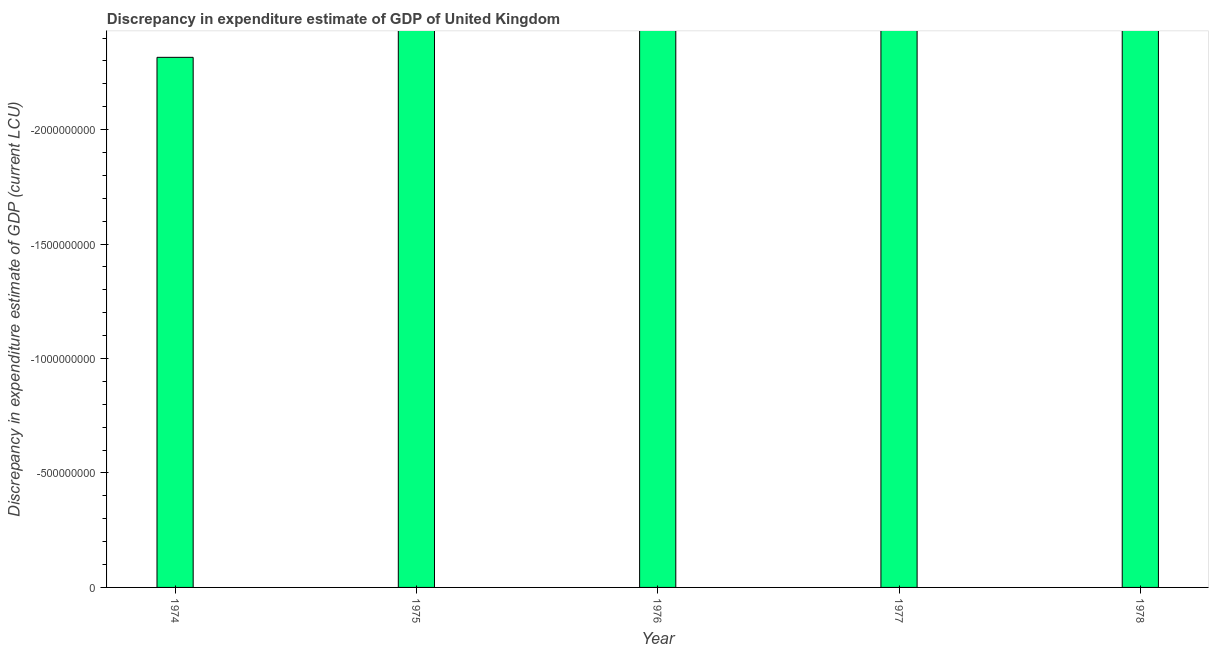Does the graph contain any zero values?
Your response must be concise. Yes. What is the title of the graph?
Your answer should be compact. Discrepancy in expenditure estimate of GDP of United Kingdom. What is the label or title of the X-axis?
Give a very brief answer. Year. What is the label or title of the Y-axis?
Your answer should be compact. Discrepancy in expenditure estimate of GDP (current LCU). What is the discrepancy in expenditure estimate of gdp in 1975?
Keep it short and to the point. 0. Across all years, what is the minimum discrepancy in expenditure estimate of gdp?
Give a very brief answer. 0. What is the sum of the discrepancy in expenditure estimate of gdp?
Provide a short and direct response. 0. In how many years, is the discrepancy in expenditure estimate of gdp greater than -500000000 LCU?
Ensure brevity in your answer.  0. In how many years, is the discrepancy in expenditure estimate of gdp greater than the average discrepancy in expenditure estimate of gdp taken over all years?
Offer a very short reply. 0. How many bars are there?
Ensure brevity in your answer.  0. How many years are there in the graph?
Offer a very short reply. 5. Are the values on the major ticks of Y-axis written in scientific E-notation?
Provide a succinct answer. No. What is the Discrepancy in expenditure estimate of GDP (current LCU) in 1974?
Your answer should be very brief. 0. What is the Discrepancy in expenditure estimate of GDP (current LCU) of 1977?
Provide a succinct answer. 0. What is the Discrepancy in expenditure estimate of GDP (current LCU) in 1978?
Give a very brief answer. 0. 